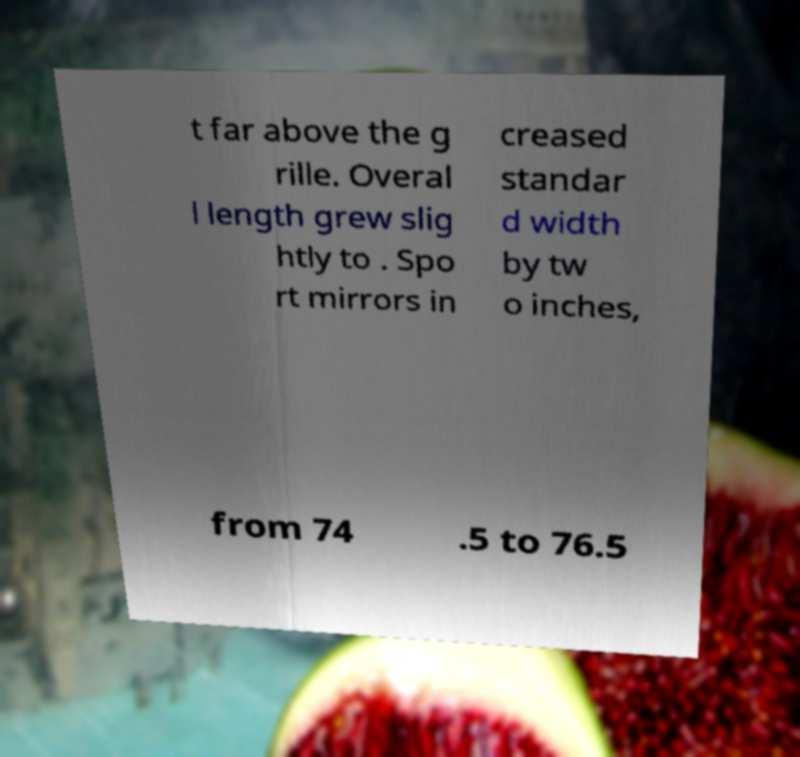For documentation purposes, I need the text within this image transcribed. Could you provide that? t far above the g rille. Overal l length grew slig htly to . Spo rt mirrors in creased standar d width by tw o inches, from 74 .5 to 76.5 